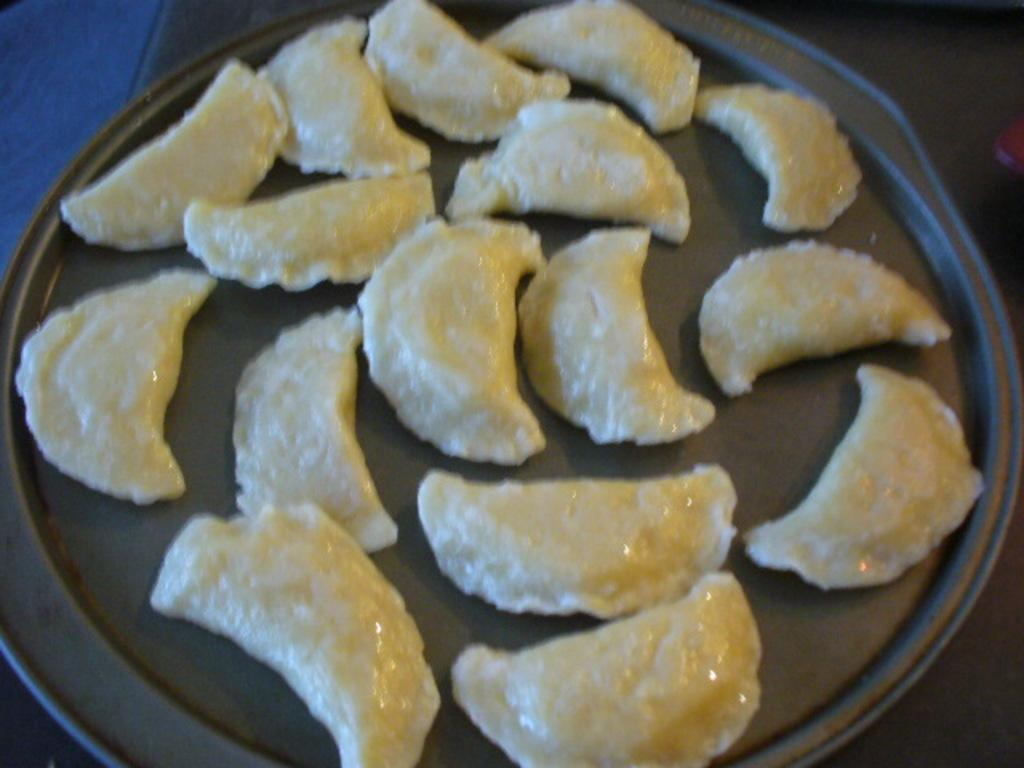What type of objects can be seen in the image? There are food items in the image. How are the food items arranged or shaped? The food items are in the shape of a half moon. Where are the food items placed? The food items are on a plate. What type of sponge is being traded in the image? There is no sponge or trade activity present in the image; it features food items in the shape of a half moon on a plate. 